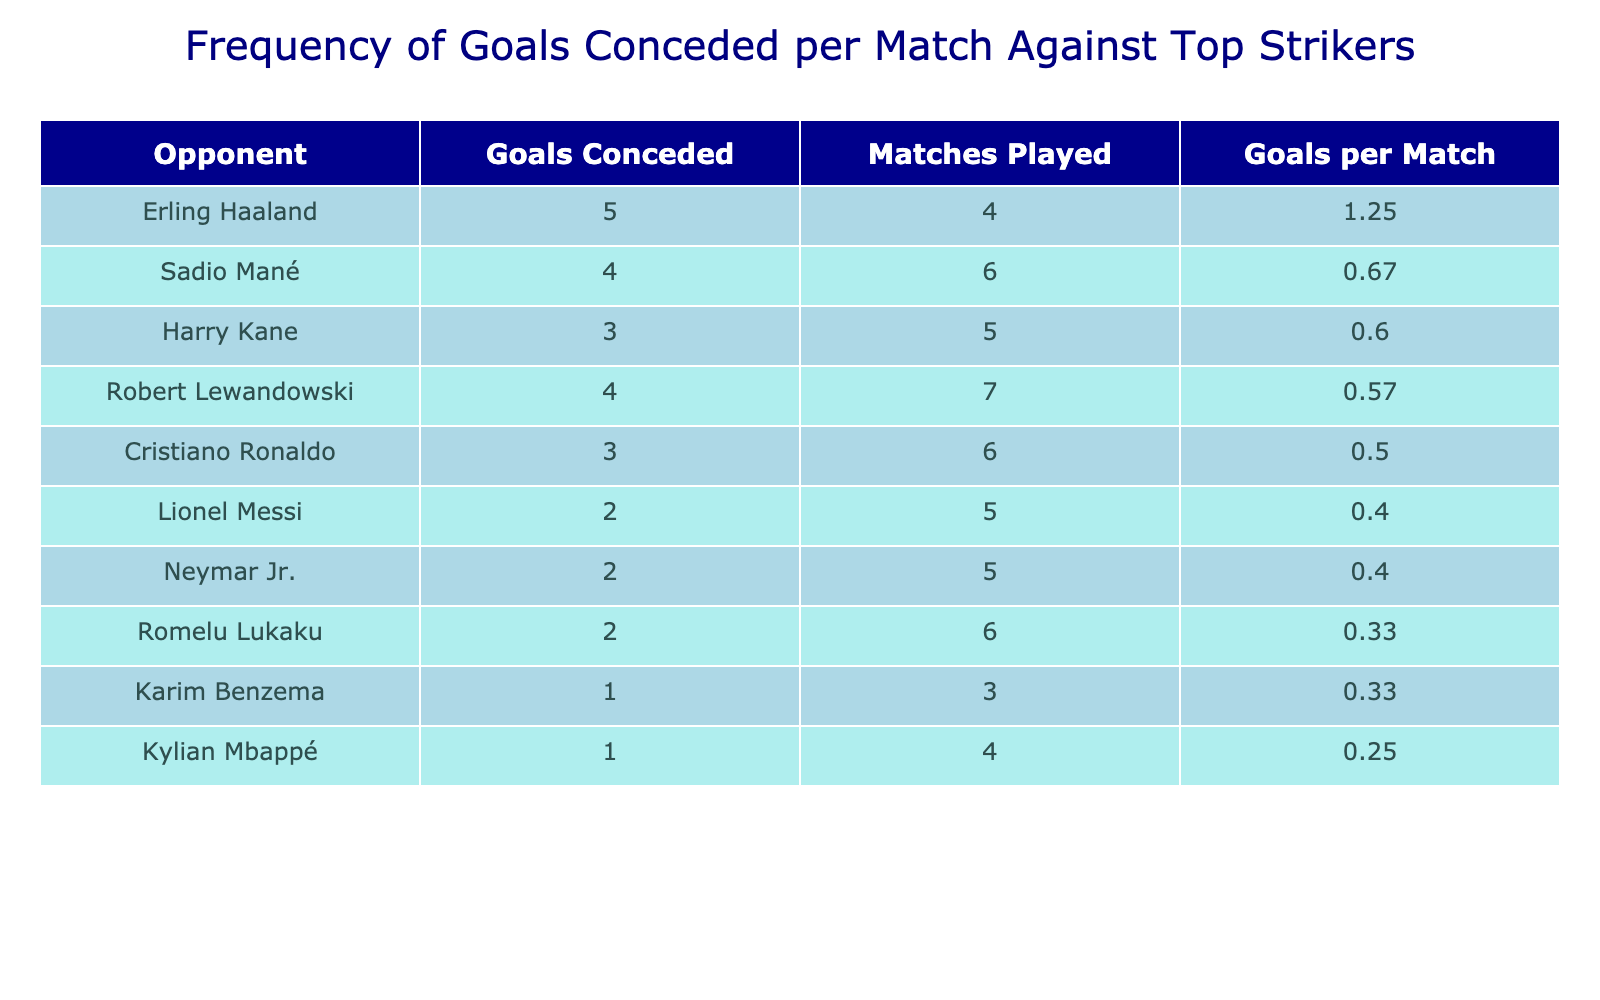What is the highest number of goals conceded per match? The highest number of goals conceded per match can be found in the "Goals per Match" column. Looking through the table, Erling Haaland has the highest value at 5 goals conceded over 4 matches, which gives 5 goals per match.
Answer: 5 Who is the opponent with the least goals conceded per match? To find the least goals conceded per match, we check the "Goals per Match" column for the lowest value. Kylian Mbappé has the least at 0.25 goals per match (1 goal over 4 matches).
Answer: Kylian Mbappé What is the average number of goals conceded per match against the top three strikers? The top three strikers based on the "Goals per Match" are Erling Haaland (5), Robert Lewandowski (4), and Sadio Mané (4). Adding these values gives us 5 + 4 + 4 = 13. There are 3 players, so we divide by 3 to find the average: 13/3 = 4.33.
Answer: 4.33 Did Romelu Lukaku concede more goals per match than Karim Benzema? To determine this, we check the "Goals per Match" values for Romelu Lukaku at 0.33 (2 goals over 6 matches) and Karim Benzema at 0.33 (1 goal over 3 matches). Since both have the same value, the answer is false.
Answer: No What is the difference in goals conceded per match between Cristiano Ronaldo and Harry Kane? The goal per match for Cristiano Ronaldo is 0.5 (3 goals over 6 matches), and for Harry Kane, it is 0.6 (3 goals over 5 matches). The difference is calculated as 0.6 - 0.5 = 0.1 goals per match.
Answer: 0.1 How many strikers conceded more than 2 goals per match? We count those in the "Goals per Match" column who scored more than 2. The players are Erling Haaland (5), Robert Lewandowski (4), Sadio Mané (4), and Cristiano Ronaldo (0.5). There are four strikers who meet this criteria.
Answer: 4 What percentage of the matches against the opponents listed resulted in more than 2 goals conceded per match? There are 10 matches total. Among them, the strikers who conceded more than 2 goals per match are Robert Lewandowski (4), Sadio Mané (4), Cristiano Ronaldo (3), and Erling Haaland (5). That sums to 4 matches, so (4/10)*100 = 40%.
Answer: 40% 